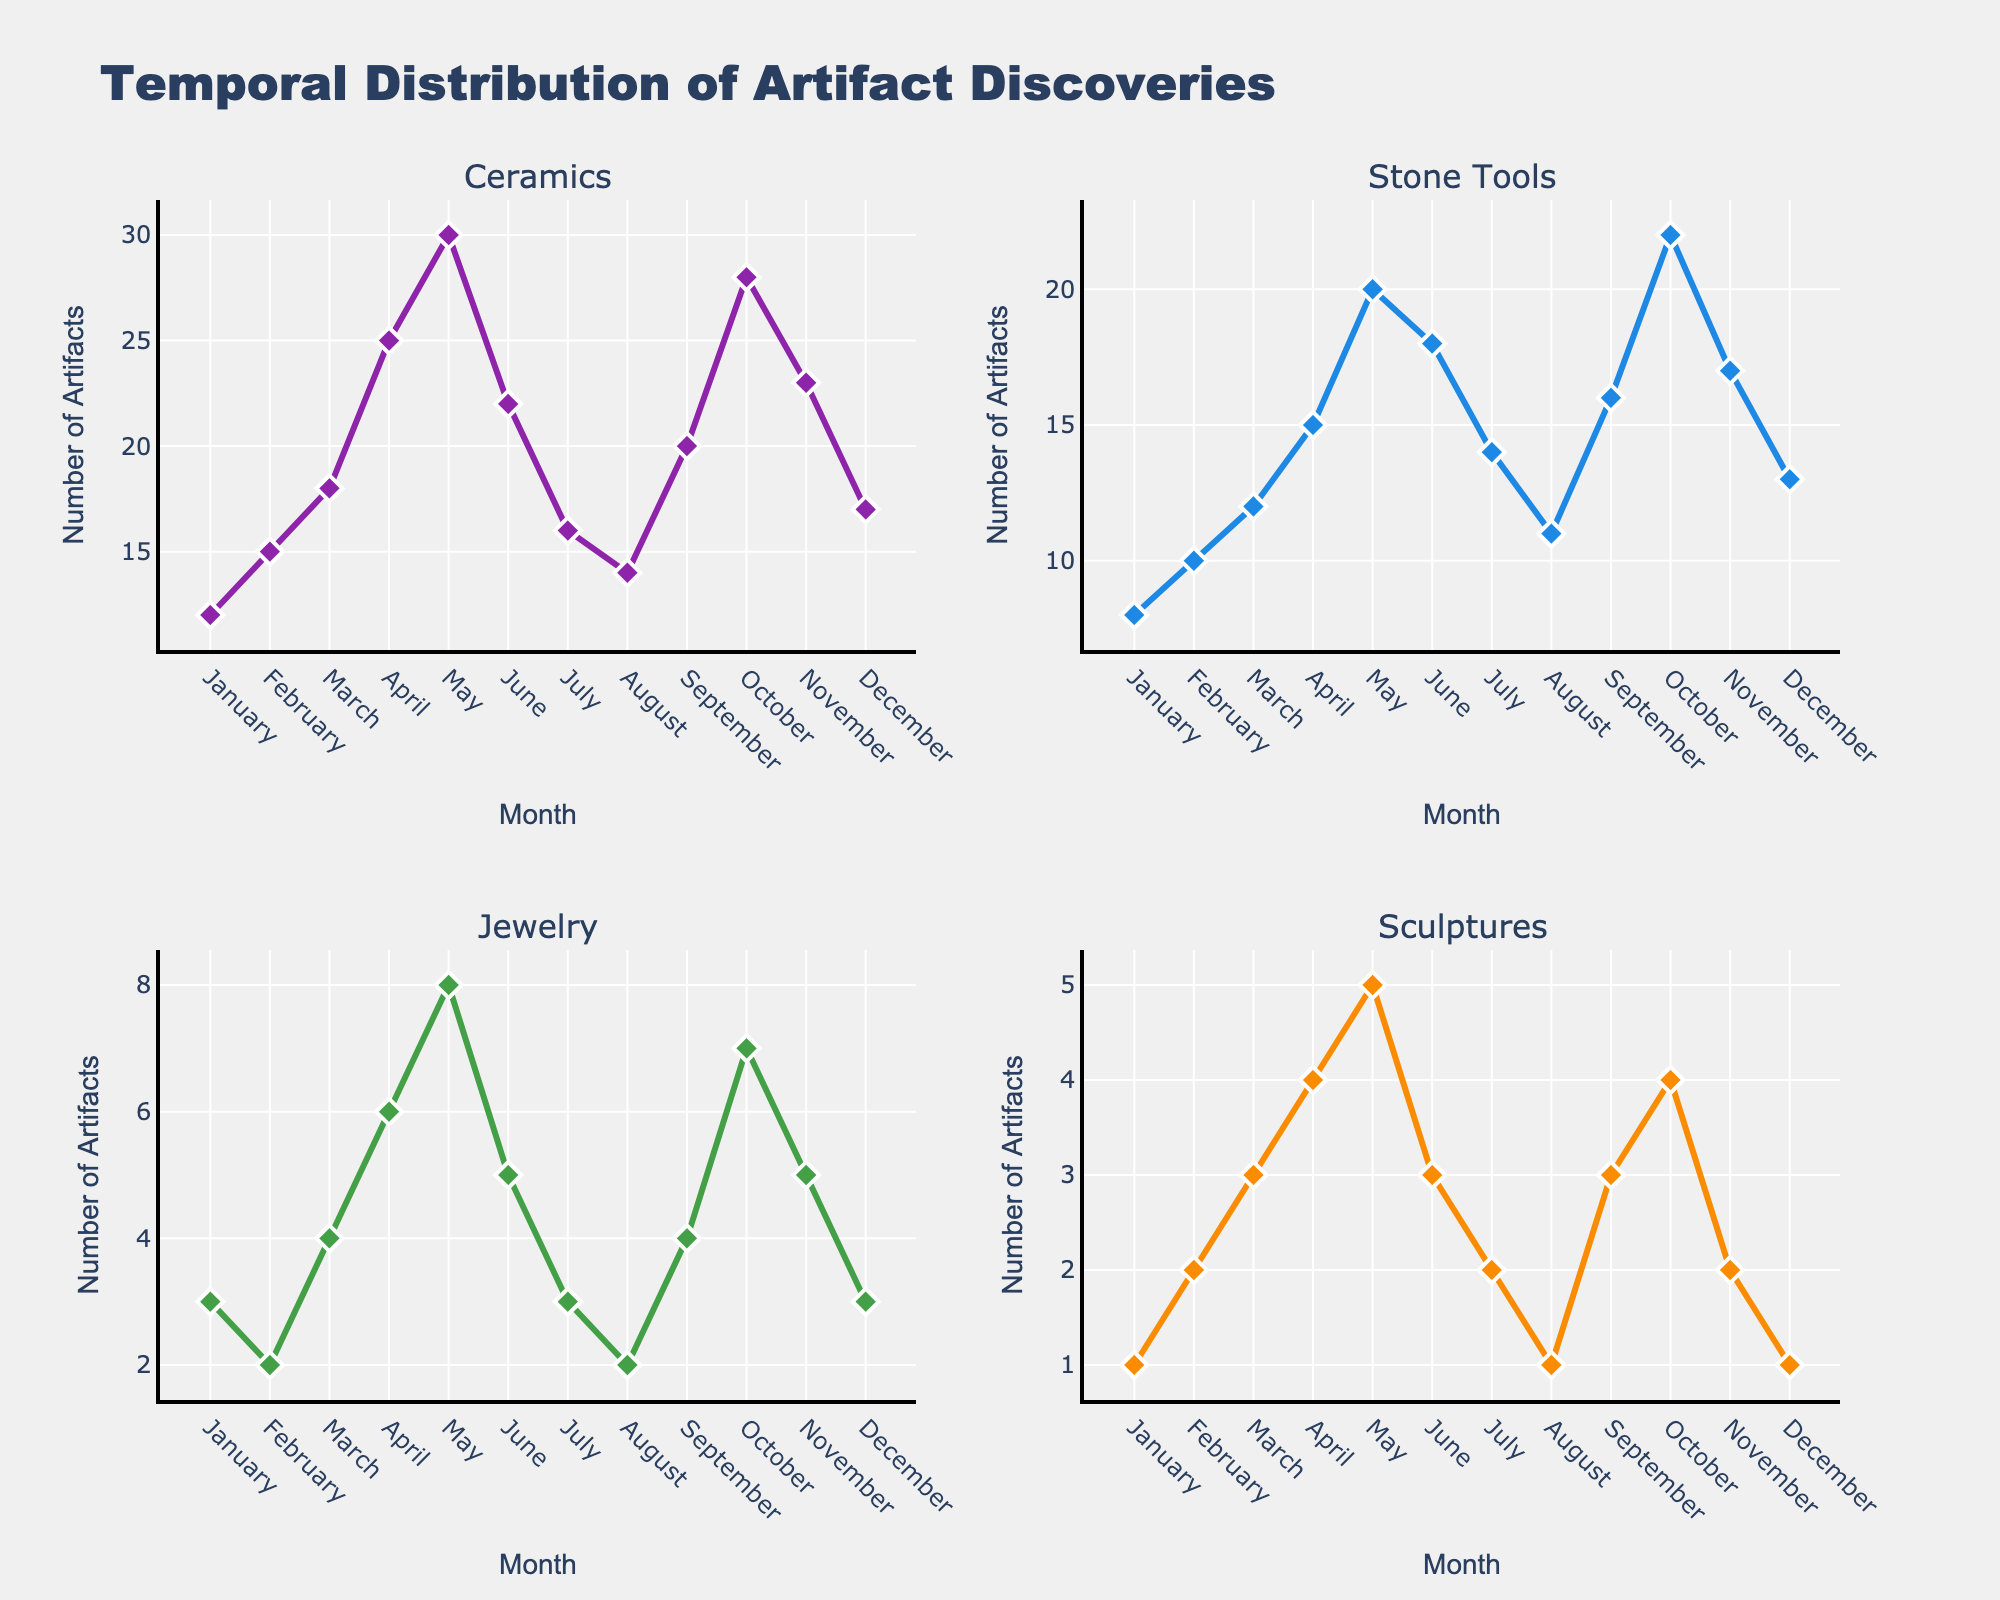What's the title of the entire figure? The title of the entire figure is located at the top of the plot, and it reads "Temporal Distribution of Artifact Discoveries".
Answer: Temporal Distribution of Artifact Discoveries What is the month with the highest number of ceramics discovered? By looking at the subplot titled "Ceramics", the month with the highest number of ceramics discovered is May, where the data point reaches 30.
Answer: May Which type of artifact has the smallest discovery count in December? In the subplot titled "Sculptures", the count reaches 1 in December. None of the other artifact types go below this number in December.
Answer: Sculptures What are the colors used for the different types of artifacts? The colors assigned to each artifact type can be observed in the figure's colored lines: purple for Ceramics, blue for Stone Tools, green for Jewelry, and orange for Sculptures.
Answer: Ceramics: purple, Stone Tools: blue, Jewelry: green, Sculptures: orange During which month do the number of stone tools and ceramics discoveries meet or cross? By examining the "Ceramics" and "Stone Tools" subplots, the discoveries for both cross in June, where stone tools (18) surpass ceramics (22).
Answer: June What is the total number of artifacts discovered in October across all types? Sum the individual counts from each subplot for October: Ceramics (28), Stone Tools (22), Jewelry (7), Sculptures (4). The total is 28 + 22 + 7 + 4 = 61.
Answer: 61 Which month shows a decline in the number of sculptures compared to the previous month? Comparing the values in the "Sculptures" subplot, December (1) shows a decline from November (2).
Answer: December In which month do we have the least number of jewelry findings, and how many were found? The "Jewelry" subplot shows that in February and August, only 2 jewelry pieces were discovered, which is the lowest number.
Answer: February and August, 2 Which artifact type shows the most consistent monthly discovery trend without steep increases or decreases? Observing all subplots, "Jewelry" shows a relatively consistent and stable trend without any steep increases or decreases.
Answer: Jewelry 